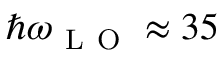Convert formula to latex. <formula><loc_0><loc_0><loc_500><loc_500>\hbar { \omega } _ { L O } \approx 3 5</formula> 